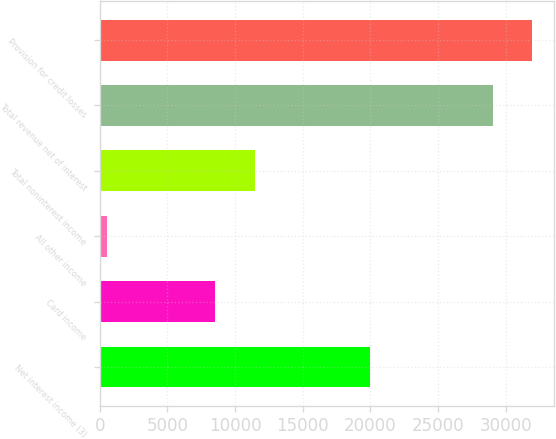<chart> <loc_0><loc_0><loc_500><loc_500><bar_chart><fcel>Net interest income (3)<fcel>Card income<fcel>All other income<fcel>Total noninterest income<fcel>Total revenue net of interest<fcel>Provision for credit losses<nl><fcel>19972<fcel>8553<fcel>521<fcel>11456.2<fcel>29046<fcel>31949.2<nl></chart> 